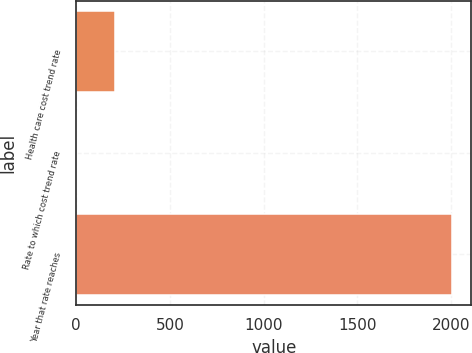<chart> <loc_0><loc_0><loc_500><loc_500><bar_chart><fcel>Health care cost trend rate<fcel>Rate to which cost trend rate<fcel>Year that rate reaches<nl><fcel>205.3<fcel>5<fcel>2008<nl></chart> 